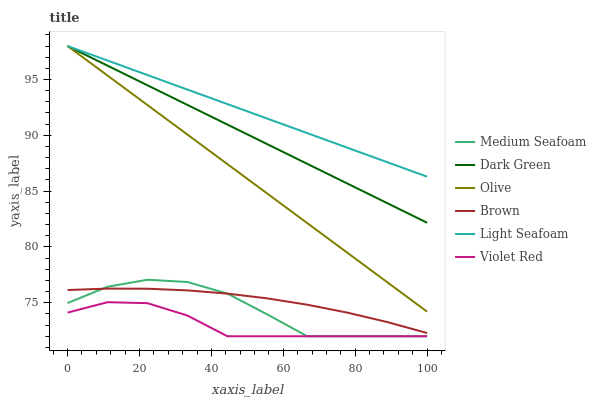Does Violet Red have the minimum area under the curve?
Answer yes or no. Yes. Does Light Seafoam have the maximum area under the curve?
Answer yes or no. Yes. Does Olive have the minimum area under the curve?
Answer yes or no. No. Does Olive have the maximum area under the curve?
Answer yes or no. No. Is Light Seafoam the smoothest?
Answer yes or no. Yes. Is Medium Seafoam the roughest?
Answer yes or no. Yes. Is Violet Red the smoothest?
Answer yes or no. No. Is Violet Red the roughest?
Answer yes or no. No. Does Violet Red have the lowest value?
Answer yes or no. Yes. Does Olive have the lowest value?
Answer yes or no. No. Does Dark Green have the highest value?
Answer yes or no. Yes. Does Violet Red have the highest value?
Answer yes or no. No. Is Brown less than Dark Green?
Answer yes or no. Yes. Is Olive greater than Violet Red?
Answer yes or no. Yes. Does Dark Green intersect Olive?
Answer yes or no. Yes. Is Dark Green less than Olive?
Answer yes or no. No. Is Dark Green greater than Olive?
Answer yes or no. No. Does Brown intersect Dark Green?
Answer yes or no. No. 